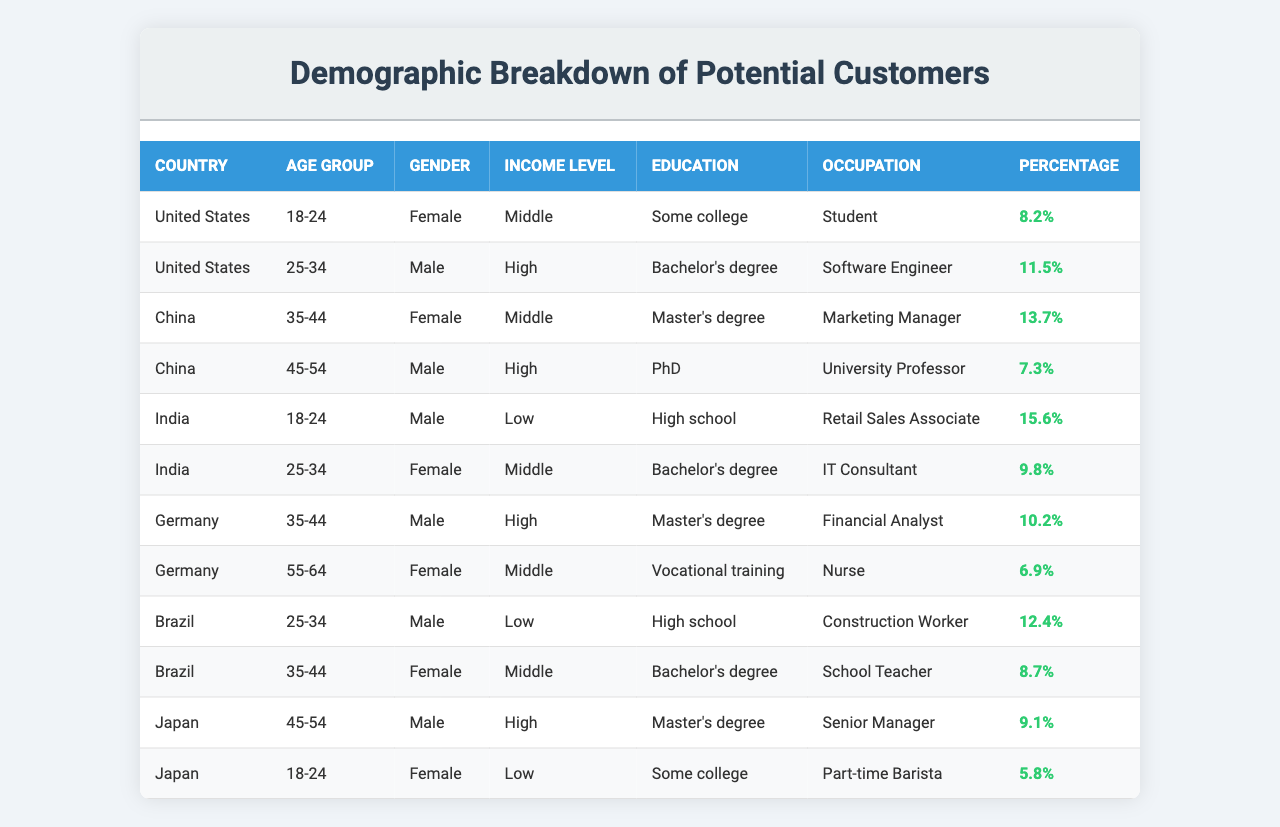What percentage of potential customers in the United States are female in the age group 18-24? There is one entry in the table for the United States with the age group 18-24 and gender female, which lists a percentage of 8.2%.
Answer: 8.2% What is the occupation of the highest percentage demographic in India? The demographic with the highest percentage in India is the 18-24 age group male with a percentage of 15.6%, whose occupation is a Retail Sales Associate.
Answer: Retail Sales Associate Is there any demographic in Brazil with a high income level and what is their percentage? In Brazil, the only demographic listed with a high income level is the 25-34 age group male, which has a percentage of 12.4%. However, the income level is classified as low for another demographic (Construction Worker), so the answer is yes based on the 25-34 male.
Answer: Yes, 12.4% Which country has the lowest percentage of customers in the age group 18-24? To find the lowest percentage, we look through the 18-24 age group across all countries. The US (8.2%), India (15.6%), and Japan (5.8%) are all considered. The lowest percentage is from Japan, which is 5.8%.
Answer: Japan, 5.8% What is the combined percentage of all female demographics in Germany? In Germany, the demographics for females are 6.9% (age 55-64) and there's no other female demographic shown. Since there's only one female demographic in the table, the combined percentage is simply 6.9%.
Answer: 6.9% Which country has more high-income males, China or Germany? In China, the only entry with a high-income male is in the age group 45-54 having 7.3%. In Germany, the 25-34 age group male has 11.5%, which is higher. Therefore, Germany has more high-income males than China.
Answer: Germany What is the average percentage of potential customers aged 35-44 across the countries listed? The percentages for the age group 35-44 are 13.7% (China), 10.2% (Germany), and 8.7% (Brazil). Adding these together gives 32.6%. Dividing by 3 (the number of entries) provides an average of 10.87%.
Answer: 10.87% What demographic in Japan has the lowest income level? In Japan, the 18-24 age group female is classified as having a low income level with a percentage of 5.8%, which is the only demographic listed with a low income level in the country.
Answer: 5.8% Which age group in China has a middle income level and what is the female percentage? The age group 35-44 in China has a middle income level with a female percentage of 13.7%.
Answer: 13.7% How does the percentage of female IT Consultants in India compare to the percentage of male Software Engineers in the United States? The percentage of female IT Consultants in India (9.8%) is compared against the percentage of male Software Engineers in the United States (11.5%). The difference is that United States (11.5%) has a higher percentage.
Answer: United States has a higher percentage 